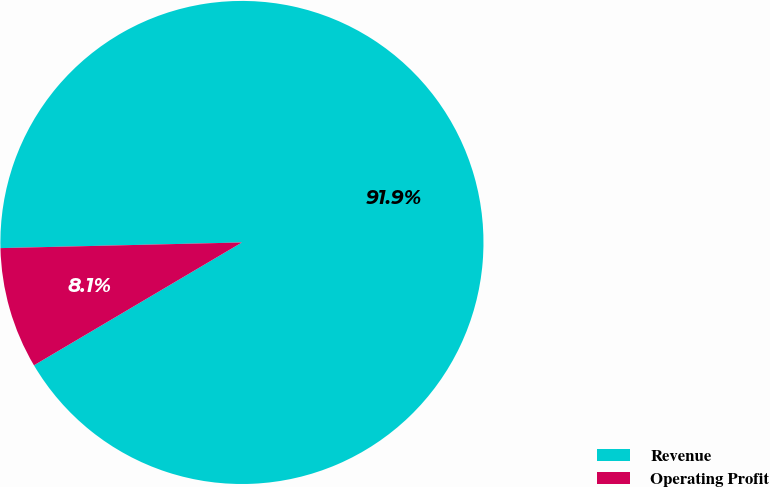Convert chart to OTSL. <chart><loc_0><loc_0><loc_500><loc_500><pie_chart><fcel>Revenue<fcel>Operating Profit<nl><fcel>91.88%<fcel>8.12%<nl></chart> 